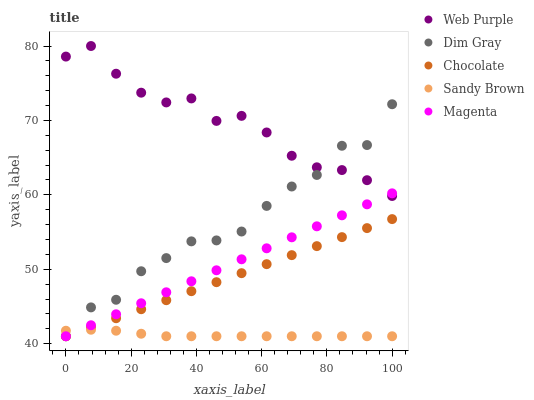Does Sandy Brown have the minimum area under the curve?
Answer yes or no. Yes. Does Web Purple have the maximum area under the curve?
Answer yes or no. Yes. Does Dim Gray have the minimum area under the curve?
Answer yes or no. No. Does Dim Gray have the maximum area under the curve?
Answer yes or no. No. Is Magenta the smoothest?
Answer yes or no. Yes. Is Dim Gray the roughest?
Answer yes or no. Yes. Is Sandy Brown the smoothest?
Answer yes or no. No. Is Sandy Brown the roughest?
Answer yes or no. No. Does Dim Gray have the lowest value?
Answer yes or no. Yes. Does Web Purple have the highest value?
Answer yes or no. Yes. Does Dim Gray have the highest value?
Answer yes or no. No. Is Sandy Brown less than Web Purple?
Answer yes or no. Yes. Is Web Purple greater than Sandy Brown?
Answer yes or no. Yes. Does Dim Gray intersect Web Purple?
Answer yes or no. Yes. Is Dim Gray less than Web Purple?
Answer yes or no. No. Is Dim Gray greater than Web Purple?
Answer yes or no. No. Does Sandy Brown intersect Web Purple?
Answer yes or no. No. 